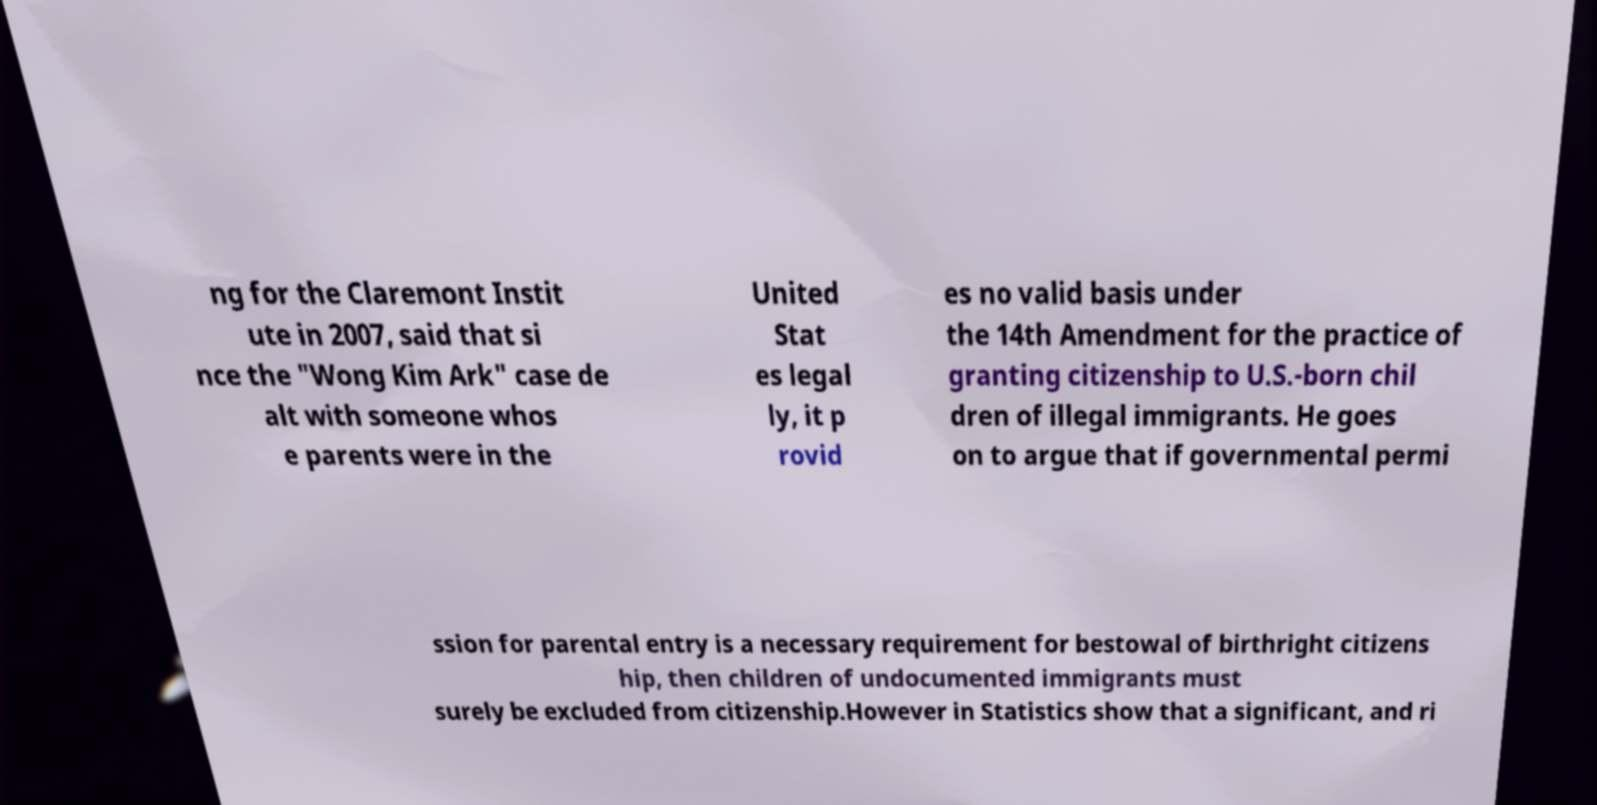Can you read and provide the text displayed in the image?This photo seems to have some interesting text. Can you extract and type it out for me? ng for the Claremont Instit ute in 2007, said that si nce the "Wong Kim Ark" case de alt with someone whos e parents were in the United Stat es legal ly, it p rovid es no valid basis under the 14th Amendment for the practice of granting citizenship to U.S.-born chil dren of illegal immigrants. He goes on to argue that if governmental permi ssion for parental entry is a necessary requirement for bestowal of birthright citizens hip, then children of undocumented immigrants must surely be excluded from citizenship.However in Statistics show that a significant, and ri 